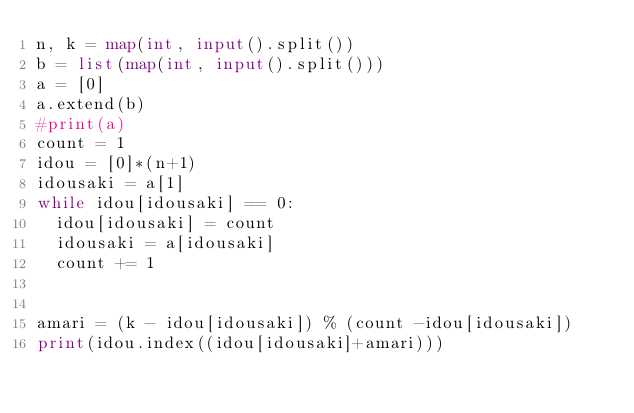Convert code to text. <code><loc_0><loc_0><loc_500><loc_500><_Python_>n, k = map(int, input().split())
b = list(map(int, input().split()))
a = [0]
a.extend(b)
#print(a)
count = 1
idou = [0]*(n+1)
idousaki = a[1]
while idou[idousaki] == 0:
  idou[idousaki] = count
  idousaki = a[idousaki]
  count += 1


amari = (k - idou[idousaki]) % (count -idou[idousaki])
print(idou.index((idou[idousaki]+amari)))</code> 